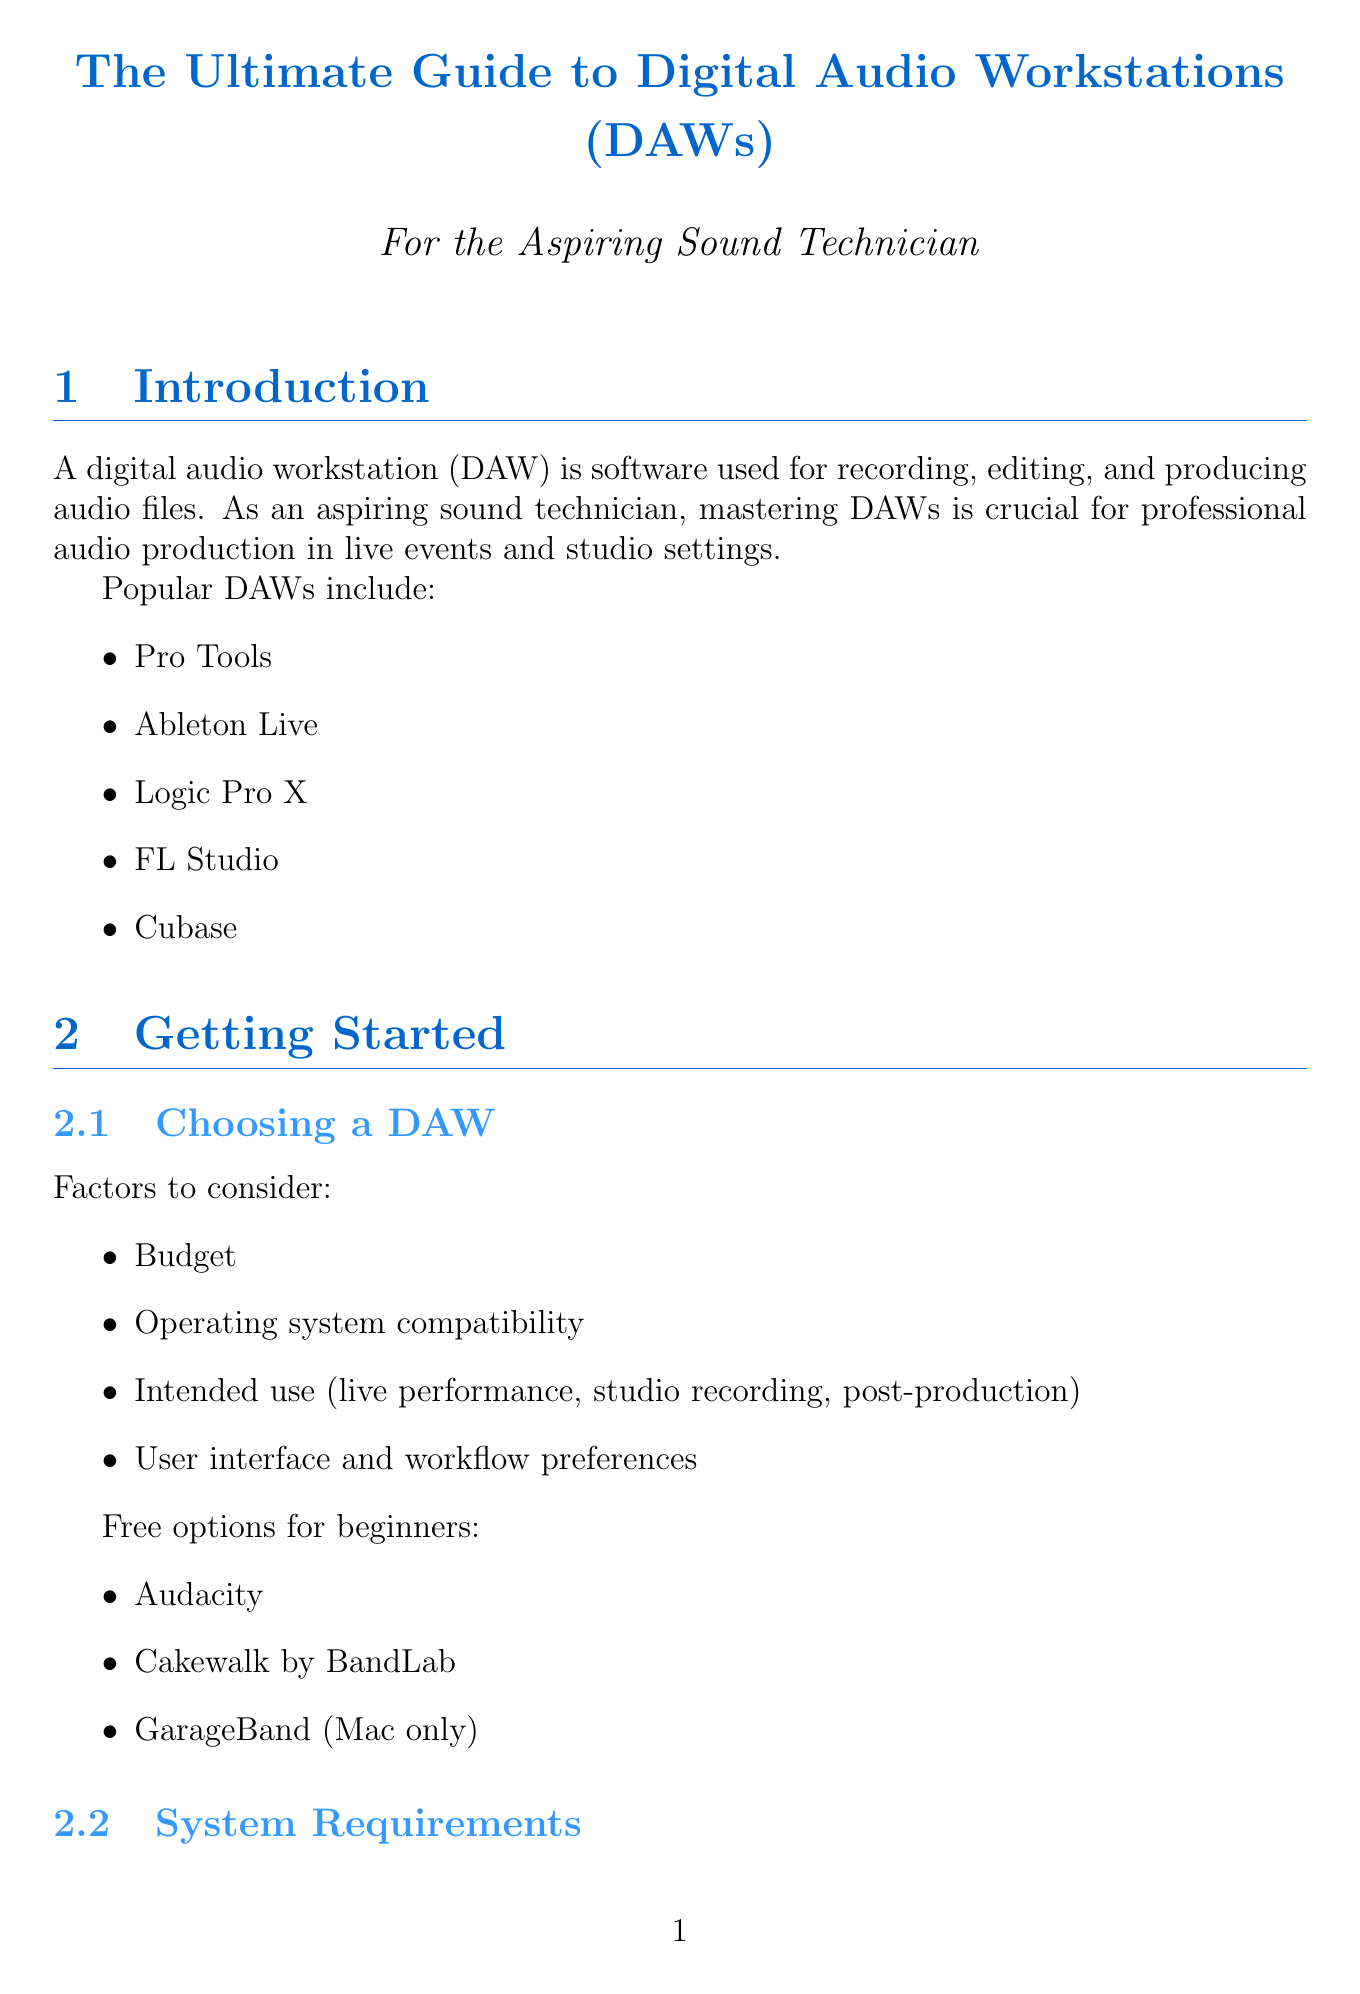What is a DAW? A DAW is defined as software used for recording, editing, and producing audio files.
Answer: software used for recording, editing, and producing audio files Which DAW is known for live performance integration? Among the listed DAWs, Ableton Live is specifically noted for its integration with live performance.
Answer: Ableton Live What should be the minimum RAM for running a DAW? The document specifies that the minimum RAM recommended for running a DAW is 8GB, with 16GB or more being ideal.
Answer: 8GB What is one free DAW option for beginners? The document lists Audacity as one of the free DAW options available for beginners.
Answer: Audacity How many basic DAW functions are listed? The document outlines four main basic DAW functions: setting up a new project, recording audio, editing tools, and mixing basics.
Answer: four What is the purpose of automation in DAWs? Automation is used for writing and editing automation data and utilizing control surfaces for hands-on mixing.
Answer: writing and editing automation data Which two topics are covered under audio processing techniques? The document mentions EQ and compression as two techniques covered under audio processing.
Answer: EQ and compression What is recommended for managing CPU resources during live recording? The document indicates the importance of managing CPU resources during live recording.
Answer: Managing CPU resources Which audio engineering meetups should a sound technician join? The document suggests joining local audio engineering meetups for continuous learning.
Answer: local audio engineering meetups 